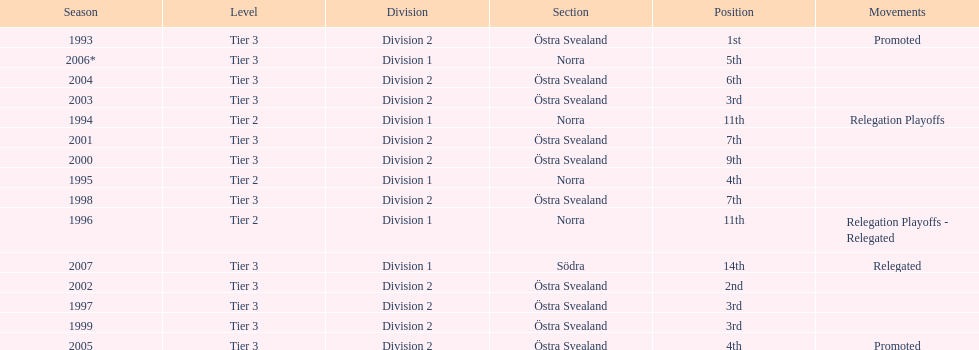What is specified under the movements column of the final season? Relegated. 